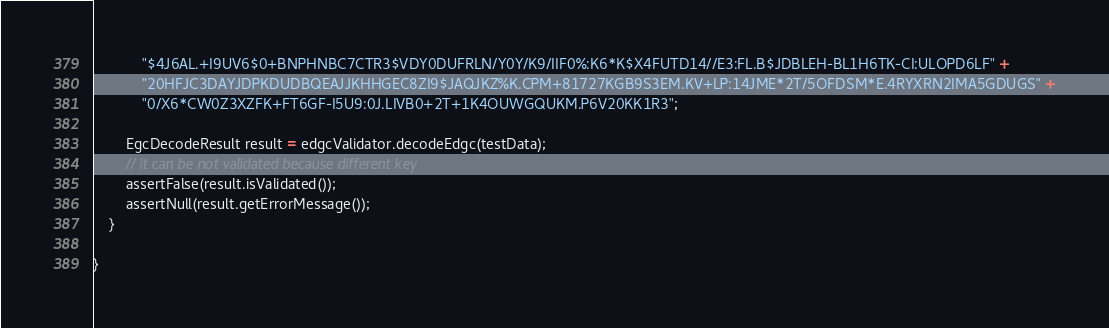Convert code to text. <code><loc_0><loc_0><loc_500><loc_500><_Java_>            "$4J6AL.+I9UV6$0+BNPHNBC7CTR3$VDY0DUFRLN/Y0Y/K9/IIF0%:K6*K$X4FUTD14//E3:FL.B$JDBLEH-BL1H6TK-CI:ULOPD6LF" +
            "20HFJC3DAYJDPKDUDBQEAJJKHHGEC8ZI9$JAQJKZ%K.CPM+81727KGB9S3EM.KV+LP:14JME*2T/5OFDSM*E.4RYXRN2IMA5GDUGS" +
            "0/X6*CW0Z3XZFK+FT6GF-I5U9:0J.LIVB0+2T+1K4OUWGQUKM.P6V20KK1R3";

        EgcDecodeResult result = edgcValidator.decodeEdgc(testData);
        // it can be not validated because different key
        assertFalse(result.isValidated());
        assertNull(result.getErrorMessage());
    }

}
</code> 